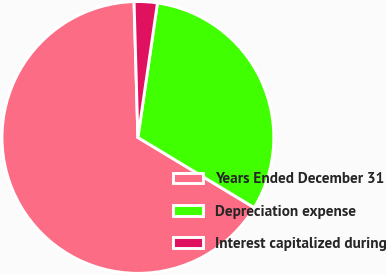<chart> <loc_0><loc_0><loc_500><loc_500><pie_chart><fcel>Years Ended December 31<fcel>Depreciation expense<fcel>Interest capitalized during<nl><fcel>65.91%<fcel>31.34%<fcel>2.75%<nl></chart> 